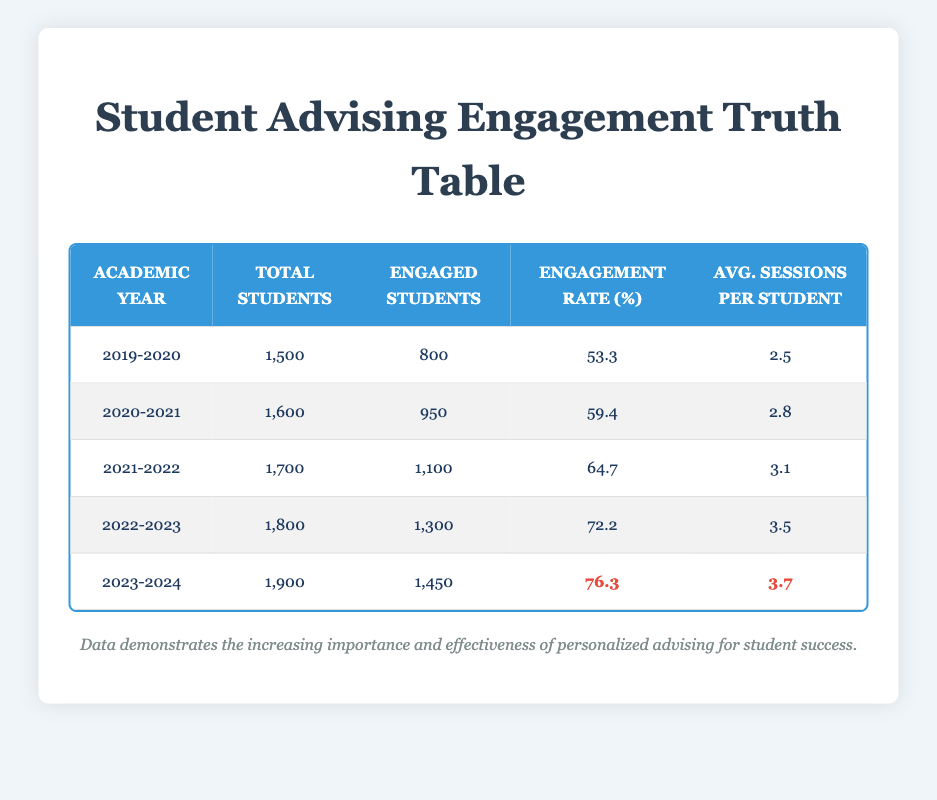What is the engagement rate for the academic year 2022-2023? Referring to the table, the engagement rate for the academic year 2022-2023 is provided directly in the corresponding row.
Answer: 72.2 How many total students were engaged in advising sessions in the academic year 2021-2022? The number of engaged students for the academic year 2021-2022 is directly visible in the table and is listed in that row.
Answer: 1100 What was the average number of sessions per student in the academic year 2020-2021? Looking at the table, the average sessions per student for the academic year 2020-2021 is found in its specific row.
Answer: 2.8 Did the engagement rate increase every year from 2019-2020 to 2023-2024? By examining the engagement rate column for each academic year, we can see that all values from 2019-2020 to 2023-2024 are progressively increasing, confirming the trend.
Answer: Yes What is the total number of engaged students from 2019-2020 to 2022-2023 combined? The total number of engaged students needs to be summed across the years 2019-2020 (800), 2020-2021 (950), 2021-2022 (1100), and 2022-2023 (1300). Thus, the total is 800 + 950 + 1100 + 1300 = 4150.
Answer: 4150 Is the engagement rate in 2023-2024 higher than the average engagement rate of the previous years (2019-2023)? First, calculate the average engagement rate for the years 2019-2023: (53.3 + 59.4 + 64.7 + 72.2)/4 = 62.4. Since 76.3 (2023-2024) is greater than 62.4, it confirms that the engagement rate has increased.
Answer: Yes What was the difference in the average sessions per student between 2019-2020 and 2022-2023? The average sessions per student for 2019-2020 is 2.5 and for 2022-2023 is 3.5. The difference is calculated as 3.5 - 2.5 = 1.0.
Answer: 1.0 What is the total number of students across all academic years provided in the table? Total students are calculated as 1500 (2019-2020) + 1600 (2020-2021) + 1700 (2021-2022) + 1800 (2022-2023) + 1900 (2023-2024) which equals 10300.
Answer: 10300 How many more students were engaged in 2023-2024 compared to 2021-2022? The number of engaged students in 2023-2024 is 1450 while in 2021-2022 it is 1100. The difference is 1450 - 1100 = 350.
Answer: 350 